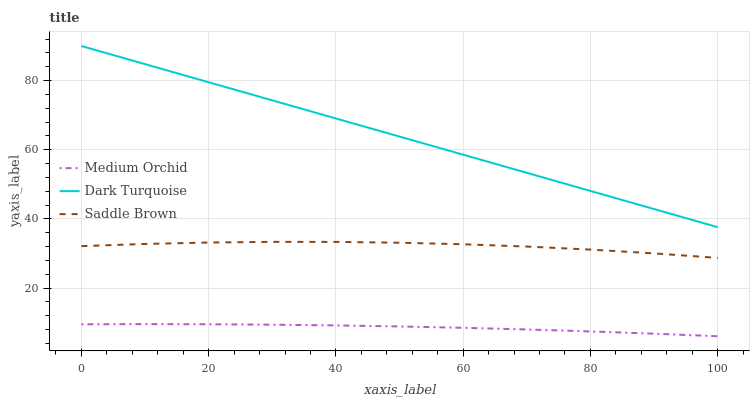Does Medium Orchid have the minimum area under the curve?
Answer yes or no. Yes. Does Dark Turquoise have the maximum area under the curve?
Answer yes or no. Yes. Does Saddle Brown have the minimum area under the curve?
Answer yes or no. No. Does Saddle Brown have the maximum area under the curve?
Answer yes or no. No. Is Dark Turquoise the smoothest?
Answer yes or no. Yes. Is Saddle Brown the roughest?
Answer yes or no. Yes. Is Medium Orchid the smoothest?
Answer yes or no. No. Is Medium Orchid the roughest?
Answer yes or no. No. Does Medium Orchid have the lowest value?
Answer yes or no. Yes. Does Saddle Brown have the lowest value?
Answer yes or no. No. Does Dark Turquoise have the highest value?
Answer yes or no. Yes. Does Saddle Brown have the highest value?
Answer yes or no. No. Is Saddle Brown less than Dark Turquoise?
Answer yes or no. Yes. Is Saddle Brown greater than Medium Orchid?
Answer yes or no. Yes. Does Saddle Brown intersect Dark Turquoise?
Answer yes or no. No. 